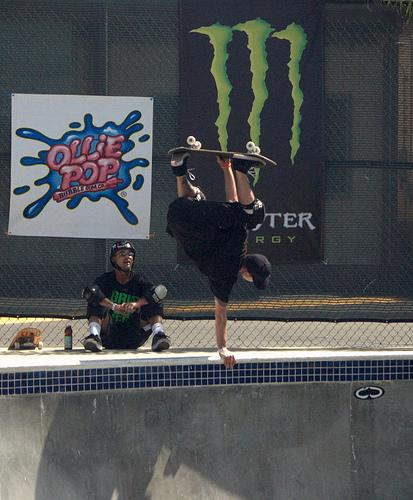What is the narcotic made popular by the poster on the wall? caffeine 